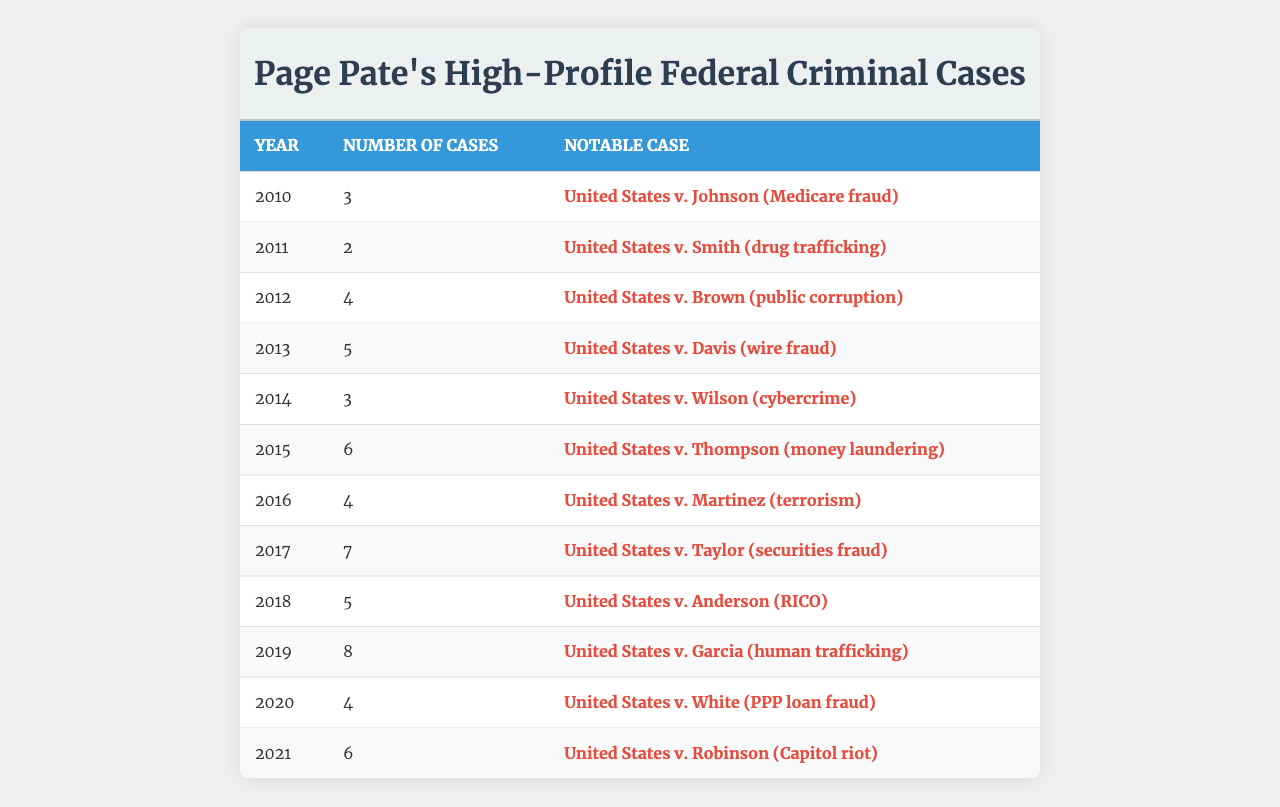What year did Page Pate handle the most high-profile federal criminal cases? By examining the table, we see that the year 2019 has the highest count of cases at 8.
Answer: 2019 How many cases did Page Pate work on in 2013? The table shows that in 2013, the count of cases was 5.
Answer: 5 Which notable case is associated with Page Pate in 2015? Referring to the table, the notable case for 2015 is "United States v. Thompson (money laundering)."
Answer: United States v. Thompson (money laundering) What is the total number of cases Page Pate was involved in from 2010 to 2016? Adding the counts from the table for the years 2010 to 2016 gives: 3 + 2 + 4 + 5 + 3 + 6 + 4 = 27.
Answer: 27 In which year was the least number of cases handled? The table shows the least number of cases in 2011, with a count of 2.
Answer: 2011 How many more cases did Page Pate handle in 2019 compared to 2012? The count for 2019 is 8 and for 2012 it is 4, so the difference is 8 - 4 = 4.
Answer: 4 Was there a year where the case count equaled 6? Yes, the years 2015 and 2021 both have a case count of 6 according to the data in the table.
Answer: Yes What is the average number of cases handled by Page Pate from 2010 to 2021? The total number of cases from 2010 to 2021 is 3 + 2 + 4 + 5 + 3 + 6 + 4 + 7 + 5 + 8 + 4 + 6 = 57. There are 12 years, so the average is 57 / 12 = 4.75.
Answer: 4.75 Which year had a notable case related to cybercrime, and how many cases did Page Pate handle that year? The year 2014 had the notable case "United States v. Wilson (cybercrime)" and the count of cases for that year was 3.
Answer: 2014, 3 Identify the trend of Page Pate's involvement in cases over the years. The table shows fluctuations, but there is a notable increase in case count from 2015 with 6 cases to 2019 with 8 cases, suggesting increased involvement in high-profile cases.
Answer: Increased involvement from 2015 to 2019 